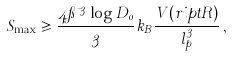Convert formula to latex. <formula><loc_0><loc_0><loc_500><loc_500>S _ { \max } \geqslant \frac { 4 \pi \mu ^ { 3 } \log D _ { 0 } } { 3 } k _ { B } \frac { V ( r i p t R ) } { l _ { p } ^ { 3 } } \, ,</formula> 